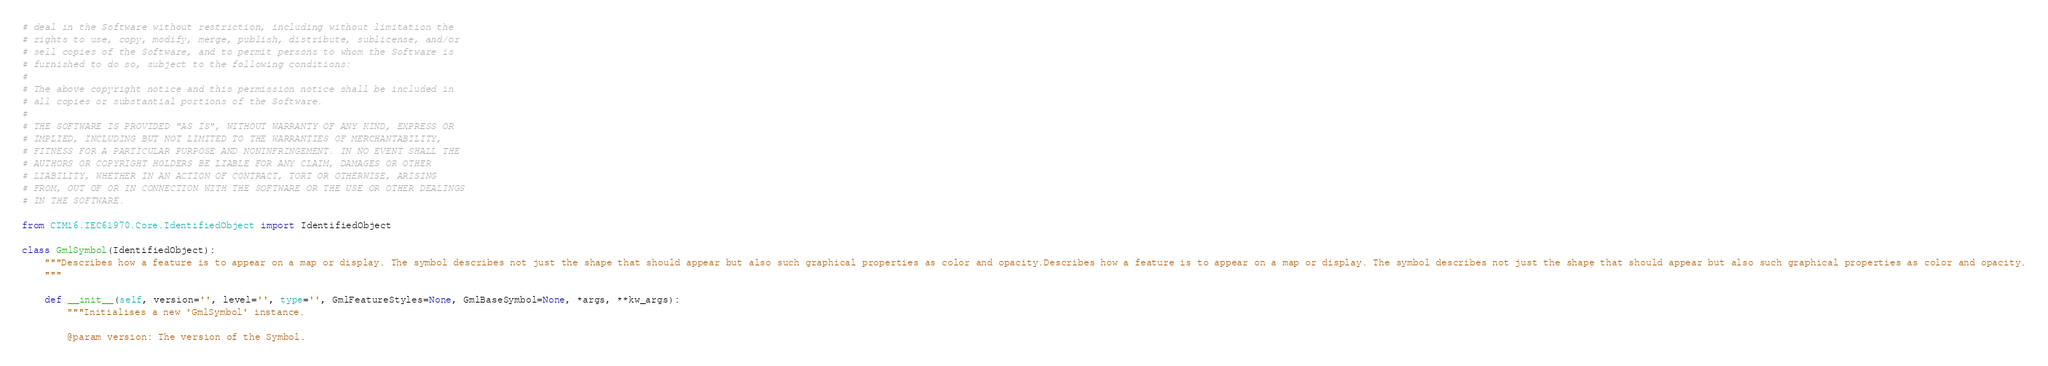<code> <loc_0><loc_0><loc_500><loc_500><_Python_># deal in the Software without restriction, including without limitation the
# rights to use, copy, modify, merge, publish, distribute, sublicense, and/or
# sell copies of the Software, and to permit persons to whom the Software is
# furnished to do so, subject to the following conditions:
#
# The above copyright notice and this permission notice shall be included in
# all copies or substantial portions of the Software.
#
# THE SOFTWARE IS PROVIDED "AS IS", WITHOUT WARRANTY OF ANY KIND, EXPRESS OR
# IMPLIED, INCLUDING BUT NOT LIMITED TO THE WARRANTIES OF MERCHANTABILITY,
# FITNESS FOR A PARTICULAR PURPOSE AND NONINFRINGEMENT. IN NO EVENT SHALL THE
# AUTHORS OR COPYRIGHT HOLDERS BE LIABLE FOR ANY CLAIM, DAMAGES OR OTHER
# LIABILITY, WHETHER IN AN ACTION OF CONTRACT, TORT OR OTHERWISE, ARISING
# FROM, OUT OF OR IN CONNECTION WITH THE SOFTWARE OR THE USE OR OTHER DEALINGS
# IN THE SOFTWARE.

from CIM16.IEC61970.Core.IdentifiedObject import IdentifiedObject

class GmlSymbol(IdentifiedObject):
    """Describes how a feature is to appear on a map or display. The symbol describes not just the shape that should appear but also such graphical properties as color and opacity.Describes how a feature is to appear on a map or display. The symbol describes not just the shape that should appear but also such graphical properties as color and opacity.
    """

    def __init__(self, version='', level='', type='', GmlFeatureStyles=None, GmlBaseSymbol=None, *args, **kw_args):
        """Initialises a new 'GmlSymbol' instance.

        @param version: The version of the Symbol. </code> 